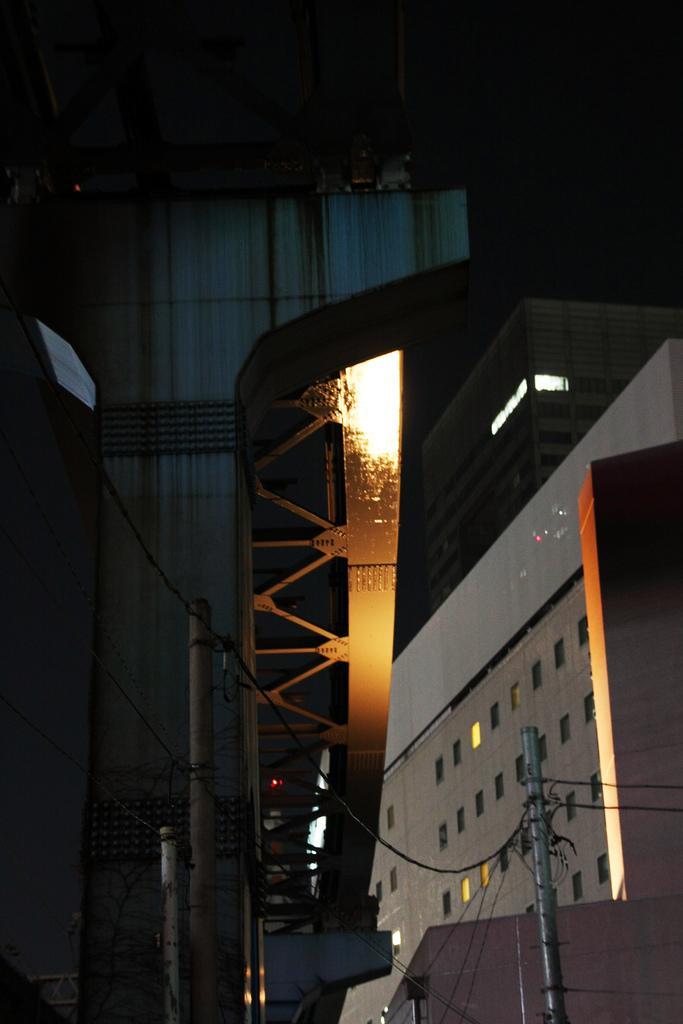Please provide a concise description of this image. There is a silver color pole, which is having cables connected. In the background, there are buildings and poles. And the background is dark in color. 